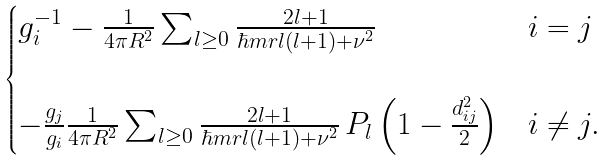<formula> <loc_0><loc_0><loc_500><loc_500>\begin{cases} g _ { i } ^ { - 1 } - \frac { 1 } { 4 \pi R ^ { 2 } } \sum _ { l \geq 0 } \frac { 2 l + 1 } { \hbar { m } r l ( l + 1 ) + \nu ^ { 2 } } & i = j \\ \\ - \frac { g _ { j } } { g _ { i } } \frac { 1 } { 4 \pi R ^ { 2 } } \sum _ { l \geq 0 } \frac { 2 l + 1 } { \hbar { m } r l ( l + 1 ) + \nu ^ { 2 } } \, P _ { l } \left ( 1 - \frac { d _ { i j } ^ { 2 } } { 2 } \right ) & i \neq j . \end{cases}</formula> 